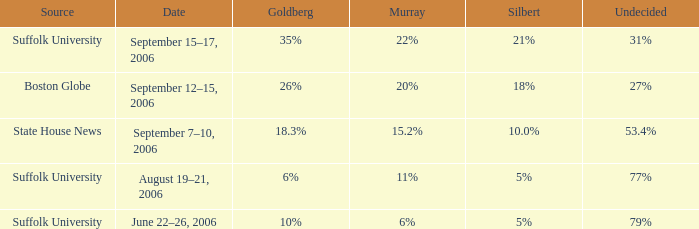What is the date of the survey where murray had 11% from the suffolk university source? August 19–21, 2006. 